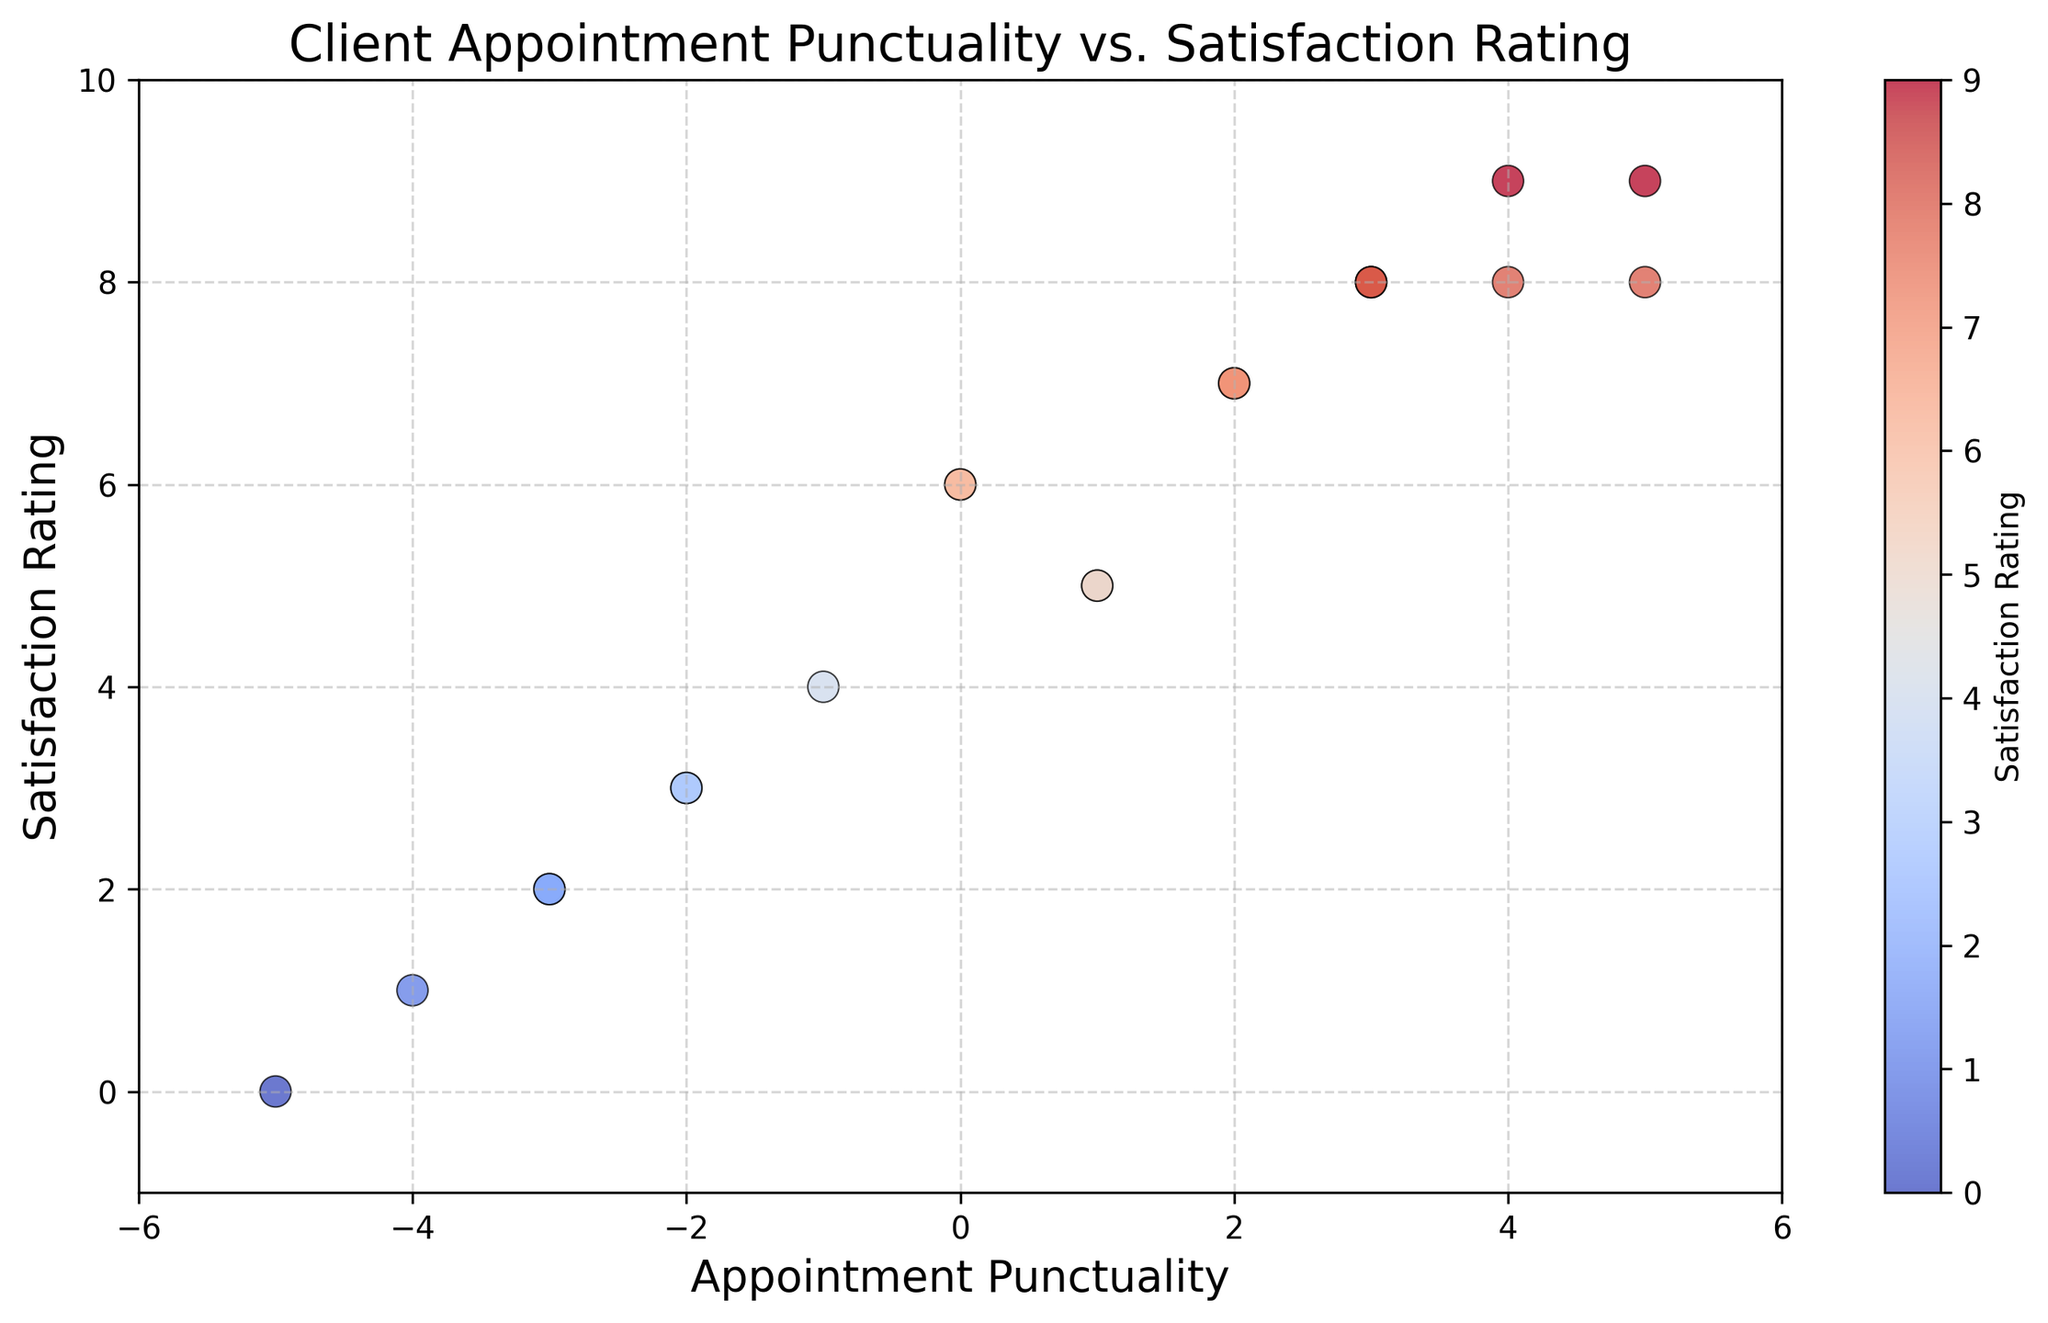What is the highest satisfaction rating given? To find the highest satisfaction rating, look at the y-axis and identify the tallest point in the scatter plot. The highest point corresponds to a satisfaction rating of 9.
Answer: 9 Which appointment punctuality value has the most varied satisfaction ratings? Examine the scatter plot for the appointment punctuality value with points spread out across different satisfaction ratings. The value 3 has a varied spread of satisfaction ratings ranging from 8 to 8.
Answer: 3 Are there more clients with positive appointment punctuality or negative appointment punctuality? Count the points to the right (positive) and to the left (negative) of the 0 on the x-axis. There are more points to the right.
Answer: Positive How many clients have a satisfaction rating of 6? Locate the y-axis at the satisfaction rating of 6 and count the number of points along this horizontal line. There are 2 such points.
Answer: 2 What is the average satisfaction rating for clients with an appointment punctuality of 2? Identify the points where the appointment punctuality is 2. The satisfaction ratings are 7 and 7. Calculate the average (7 + 7) / 2 = 7.
Answer: 7 Which client had the lowest satisfaction rating and what was their appointment punctuality? Find the lowest point on the y-axis. The lowest satisfaction rating is 0, and the corresponding appointment punctuality is -5.
Answer: -5 Is there a general trend between appointment punctuality and satisfaction rating? Observe the overall direction of points from left to right. A positive punctuality tends to correspond with higher satisfaction, suggesting a positive correlation.
Answer: Positive correlation How many clients have an appointment punctuality between -2 and 4 inclusive? Count the points from -2 to 4 on the x-axis inclusive. There are 2 + 1 + 1 + 5 = 9 points.
Answer: 9 What is the difference in satisfaction rating between the most punctual client and the least punctual client? The most punctual client has a punctuality rating of 5 and a satisfaction rating of 9. The least punctual client has a punctuality rating of -5 and a satisfaction rating of 0. The difference is 9 - 0 = 9.
Answer: 9 